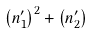Convert formula to latex. <formula><loc_0><loc_0><loc_500><loc_500>\left ( n _ { 1 } ^ { \prime } \right ) ^ { 2 } + \left ( n _ { 2 } ^ { \prime } \right )</formula> 